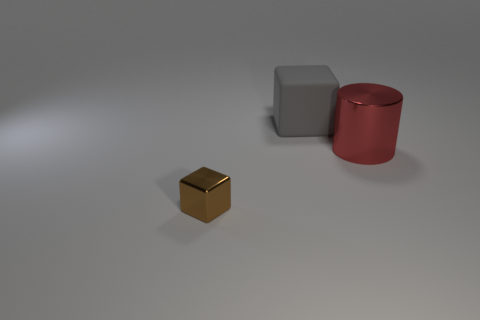How many cubes are tiny purple rubber things or brown objects?
Your response must be concise. 1. Are any metallic blocks visible?
Provide a succinct answer. Yes. What number of other things are there of the same material as the gray block
Your answer should be very brief. 0. What is the material of the gray thing that is the same size as the red cylinder?
Make the answer very short. Rubber. Do the thing on the right side of the large gray matte object and the big gray thing have the same shape?
Offer a terse response. No. Is the color of the small thing the same as the big cylinder?
Offer a very short reply. No. How many things are either blocks in front of the matte block or large gray metallic cylinders?
Keep it short and to the point. 1. What shape is the gray thing that is the same size as the red object?
Make the answer very short. Cube. Is the size of the metal thing that is left of the cylinder the same as the rubber cube that is on the left side of the cylinder?
Keep it short and to the point. No. The cylinder that is made of the same material as the tiny brown block is what color?
Offer a terse response. Red. 